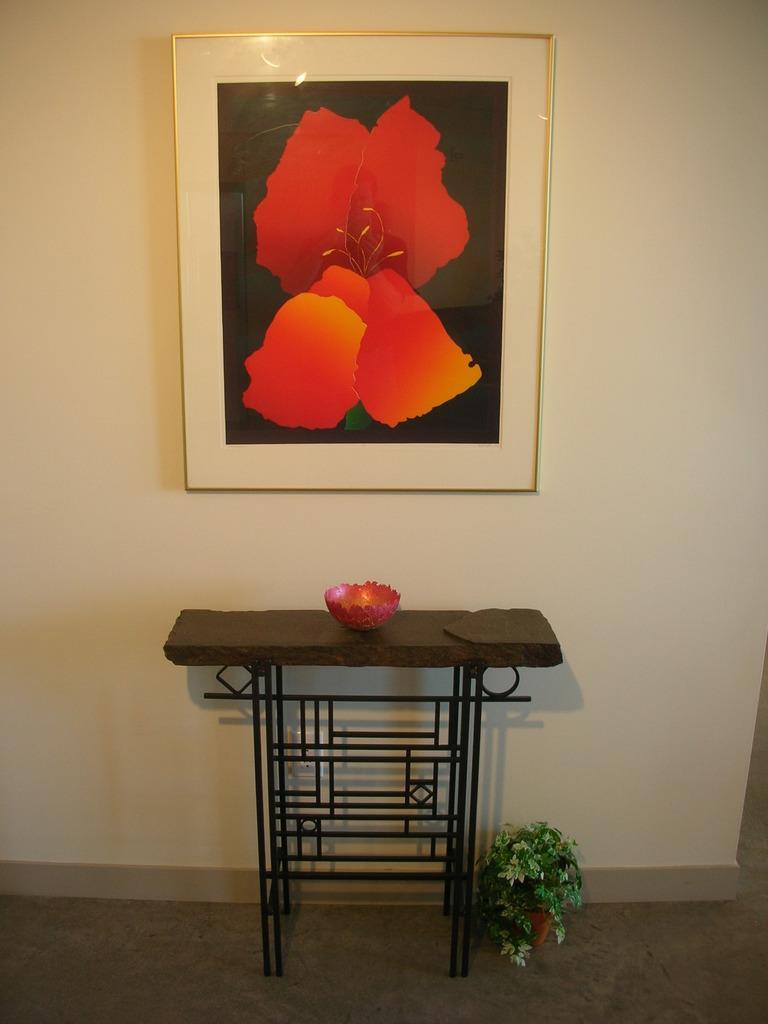Could you give a brief overview of what you see in this image? In this image there is a table having a bowl. Beside the table there is a pot having a plant. A picture frame is attached to the wall. 